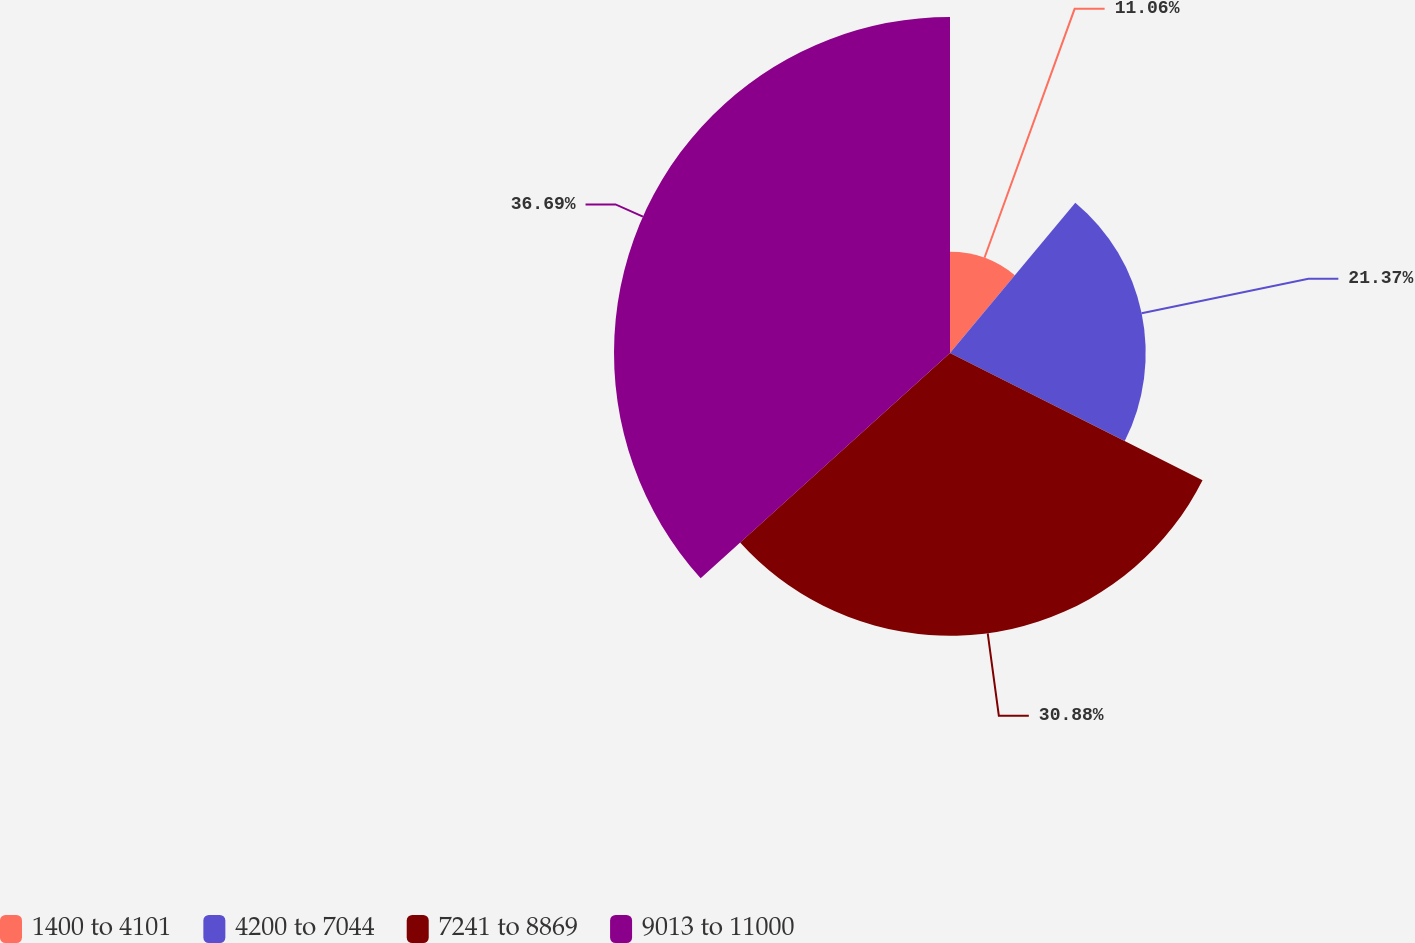<chart> <loc_0><loc_0><loc_500><loc_500><pie_chart><fcel>1400 to 4101<fcel>4200 to 7044<fcel>7241 to 8869<fcel>9013 to 11000<nl><fcel>11.06%<fcel>21.37%<fcel>30.88%<fcel>36.69%<nl></chart> 